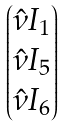<formula> <loc_0><loc_0><loc_500><loc_500>\begin{pmatrix} \hat { \nu } I _ { 1 } \\ \hat { \nu } I _ { 5 } \\ \hat { \nu } I _ { 6 } \\ \end{pmatrix}</formula> 